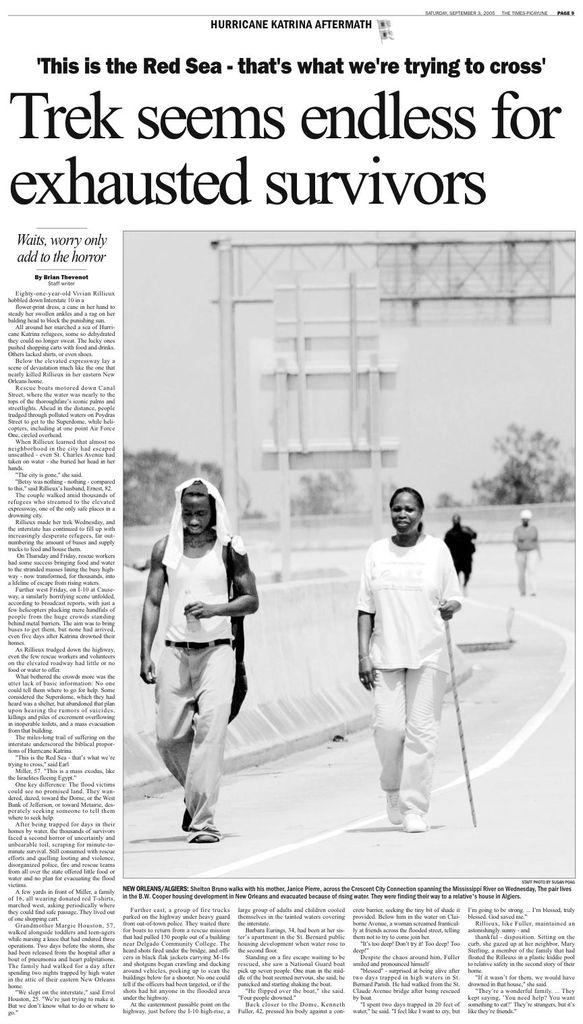What type of media is the image? The image is a newspaper. What can be seen happening in the image? There are four people on the road in the image. What is visible in the background of the image? There are trees and boards in the background of the image. What type of shoe is being advertised in the newspaper? There is no shoe being advertised in the image, as the image is a newspaper with a scene of four people on the road. What fictional character is mentioned in the newspaper? The image is a photograph of a scene, not a written article, so there are no fictional characters mentioned in the image. 